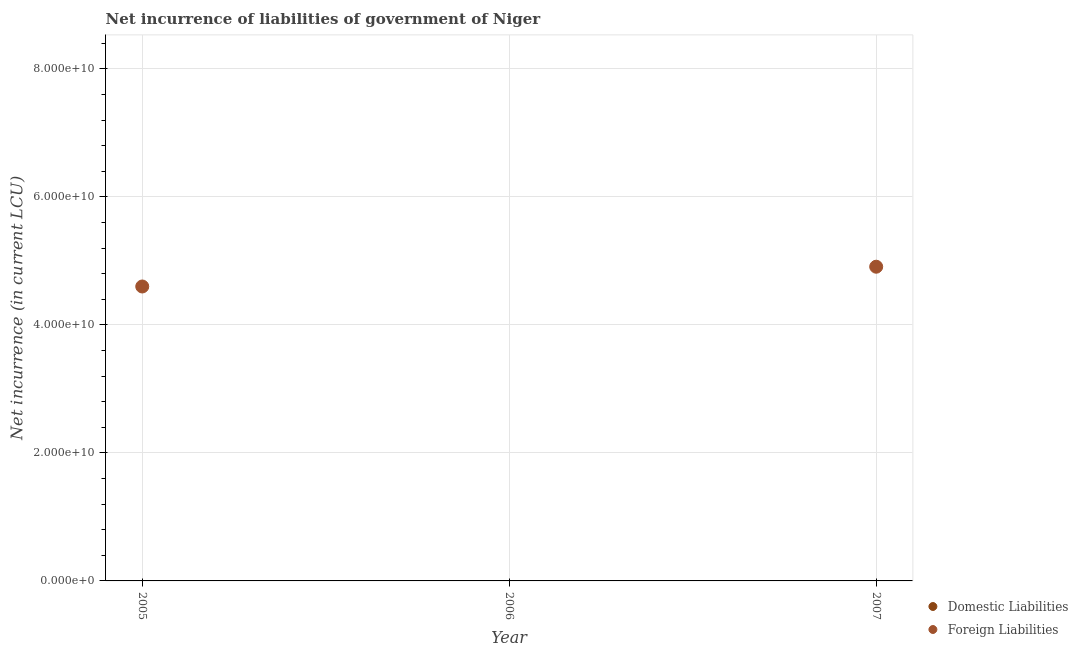How many different coloured dotlines are there?
Offer a very short reply. 1. What is the net incurrence of foreign liabilities in 2005?
Provide a short and direct response. 4.60e+1. Across all years, what is the maximum net incurrence of foreign liabilities?
Offer a very short reply. 4.91e+1. In which year was the net incurrence of foreign liabilities maximum?
Your answer should be compact. 2007. What is the total net incurrence of foreign liabilities in the graph?
Offer a terse response. 9.51e+1. What is the difference between the net incurrence of foreign liabilities in 2007 and the net incurrence of domestic liabilities in 2006?
Your answer should be compact. 4.91e+1. What is the average net incurrence of domestic liabilities per year?
Offer a terse response. 0. What is the ratio of the net incurrence of foreign liabilities in 2005 to that in 2007?
Your answer should be very brief. 0.94. Is the net incurrence of foreign liabilities in 2005 less than that in 2007?
Give a very brief answer. Yes. What is the difference between the highest and the lowest net incurrence of foreign liabilities?
Your response must be concise. 4.91e+1. Does the net incurrence of foreign liabilities monotonically increase over the years?
Give a very brief answer. No. How many dotlines are there?
Provide a short and direct response. 1. How many years are there in the graph?
Provide a succinct answer. 3. What is the difference between two consecutive major ticks on the Y-axis?
Your response must be concise. 2.00e+1. Does the graph contain grids?
Your answer should be very brief. Yes. Where does the legend appear in the graph?
Provide a short and direct response. Bottom right. How are the legend labels stacked?
Provide a succinct answer. Vertical. What is the title of the graph?
Ensure brevity in your answer.  Net incurrence of liabilities of government of Niger. Does "Constant 2005 US$" appear as one of the legend labels in the graph?
Give a very brief answer. No. What is the label or title of the X-axis?
Your answer should be compact. Year. What is the label or title of the Y-axis?
Your answer should be compact. Net incurrence (in current LCU). What is the Net incurrence (in current LCU) in Domestic Liabilities in 2005?
Your answer should be very brief. 0. What is the Net incurrence (in current LCU) in Foreign Liabilities in 2005?
Keep it short and to the point. 4.60e+1. What is the Net incurrence (in current LCU) of Domestic Liabilities in 2006?
Provide a succinct answer. 0. What is the Net incurrence (in current LCU) of Foreign Liabilities in 2007?
Provide a succinct answer. 4.91e+1. Across all years, what is the maximum Net incurrence (in current LCU) in Foreign Liabilities?
Make the answer very short. 4.91e+1. Across all years, what is the minimum Net incurrence (in current LCU) in Foreign Liabilities?
Provide a succinct answer. 0. What is the total Net incurrence (in current LCU) of Domestic Liabilities in the graph?
Offer a very short reply. 0. What is the total Net incurrence (in current LCU) of Foreign Liabilities in the graph?
Provide a succinct answer. 9.51e+1. What is the difference between the Net incurrence (in current LCU) in Foreign Liabilities in 2005 and that in 2007?
Provide a short and direct response. -3.09e+09. What is the average Net incurrence (in current LCU) of Foreign Liabilities per year?
Ensure brevity in your answer.  3.17e+1. What is the ratio of the Net incurrence (in current LCU) of Foreign Liabilities in 2005 to that in 2007?
Offer a terse response. 0.94. What is the difference between the highest and the lowest Net incurrence (in current LCU) of Foreign Liabilities?
Your response must be concise. 4.91e+1. 